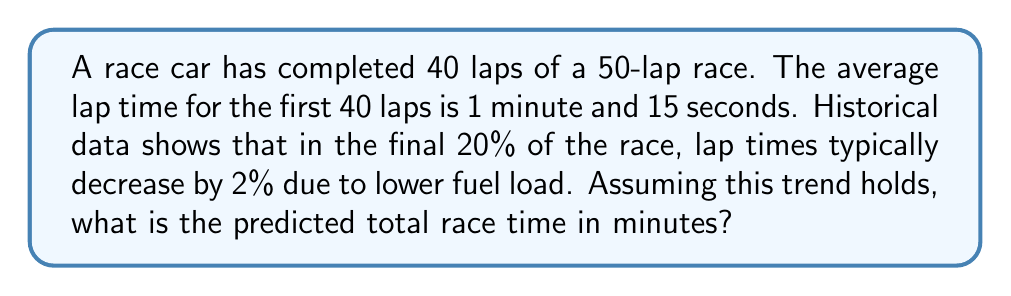Could you help me with this problem? Let's approach this step-by-step:

1) First, calculate the total time for the first 40 laps:
   $40 \times 1.25 \text{ minutes} = 50 \text{ minutes}$

2) For the remaining 10 laps, we need to adjust the lap time:
   Original lap time: 1 minute 15 seconds = 1.25 minutes
   Adjusted lap time: $1.25 \times 0.98 = 1.225 \text{ minutes}$

3) Calculate the time for the final 10 laps:
   $10 \times 1.225 \text{ minutes} = 12.25 \text{ minutes}$

4) Sum the times for all 50 laps:
   $50 \text{ minutes} + 12.25 \text{ minutes} = 62.25 \text{ minutes}$

Therefore, the predicted total race time is 62.25 minutes.
Answer: 62.25 minutes 